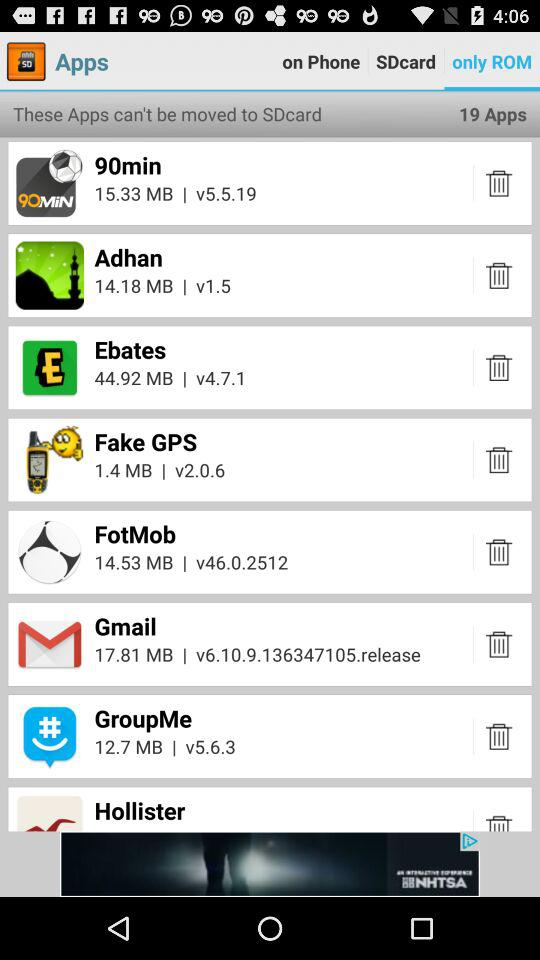What is the size of the "Fake GPS"? The size of the "Fake GPS" is 1.4 MB. 